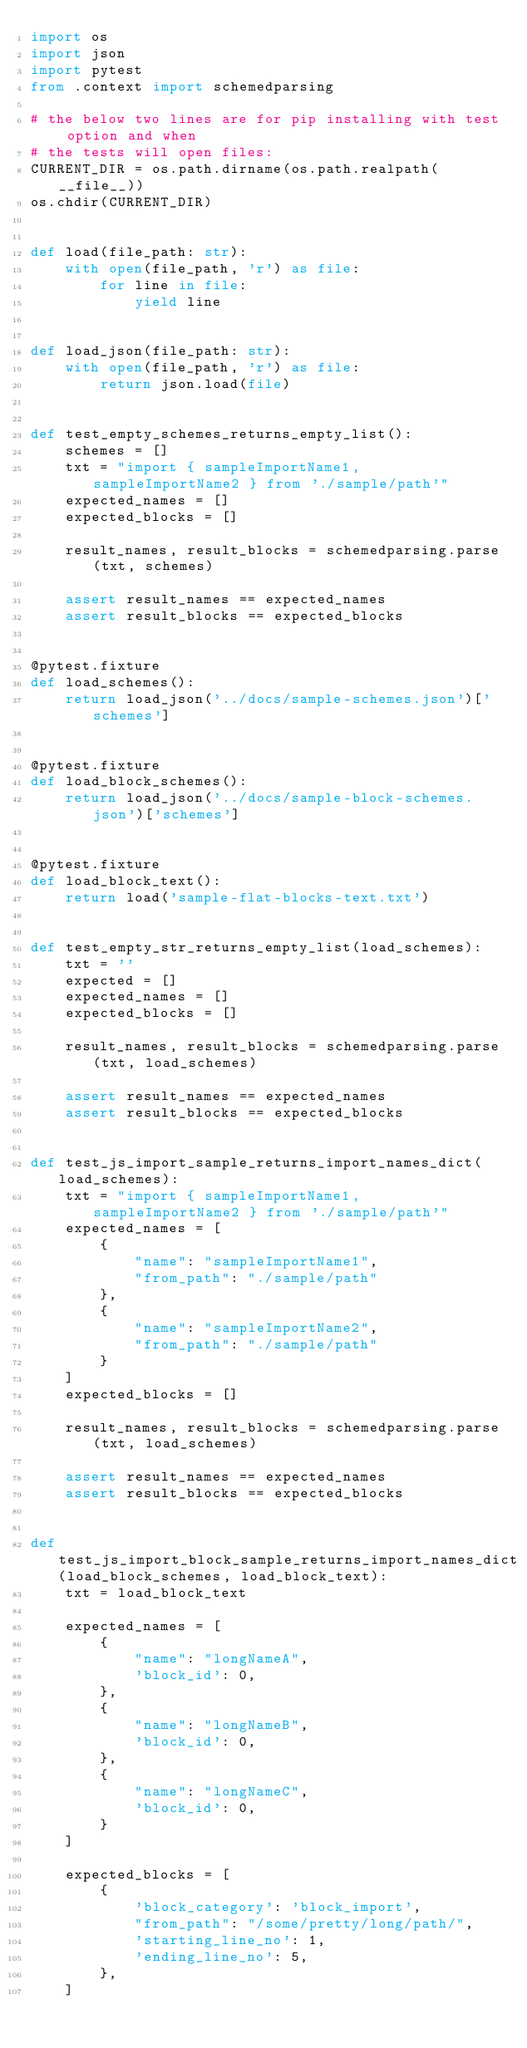<code> <loc_0><loc_0><loc_500><loc_500><_Python_>import os
import json
import pytest
from .context import schemedparsing

# the below two lines are for pip installing with test option and when
# the tests will open files:
CURRENT_DIR = os.path.dirname(os.path.realpath(__file__))
os.chdir(CURRENT_DIR)


def load(file_path: str):
    with open(file_path, 'r') as file:
        for line in file:
            yield line


def load_json(file_path: str):
    with open(file_path, 'r') as file:
        return json.load(file)


def test_empty_schemes_returns_empty_list():
    schemes = []
    txt = "import { sampleImportName1, sampleImportName2 } from './sample/path'"
    expected_names = []
    expected_blocks = []

    result_names, result_blocks = schemedparsing.parse(txt, schemes)

    assert result_names == expected_names
    assert result_blocks == expected_blocks


@pytest.fixture
def load_schemes():
    return load_json('../docs/sample-schemes.json')['schemes']


@pytest.fixture
def load_block_schemes():
    return load_json('../docs/sample-block-schemes.json')['schemes']


@pytest.fixture
def load_block_text():
    return load('sample-flat-blocks-text.txt')


def test_empty_str_returns_empty_list(load_schemes):
    txt = ''
    expected = []
    expected_names = []
    expected_blocks = []

    result_names, result_blocks = schemedparsing.parse(txt, load_schemes)

    assert result_names == expected_names
    assert result_blocks == expected_blocks


def test_js_import_sample_returns_import_names_dict(load_schemes):
    txt = "import { sampleImportName1, sampleImportName2 } from './sample/path'"
    expected_names = [
        {
            "name": "sampleImportName1",
            "from_path": "./sample/path"
        },
        {
            "name": "sampleImportName2",
            "from_path": "./sample/path"
        }
    ]
    expected_blocks = []

    result_names, result_blocks = schemedparsing.parse(txt, load_schemes)

    assert result_names == expected_names
    assert result_blocks == expected_blocks


def test_js_import_block_sample_returns_import_names_dict(load_block_schemes, load_block_text):
    txt = load_block_text

    expected_names = [
        {
            "name": "longNameA",
            'block_id': 0,
        },
        {
            "name": "longNameB",
            'block_id': 0,
        },
        {
            "name": "longNameC",
            'block_id': 0,
        }
    ]

    expected_blocks = [
        {
            'block_category': 'block_import',
            "from_path": "/some/pretty/long/path/",
            'starting_line_no': 1,
            'ending_line_no': 5,
        },
    ]
</code> 